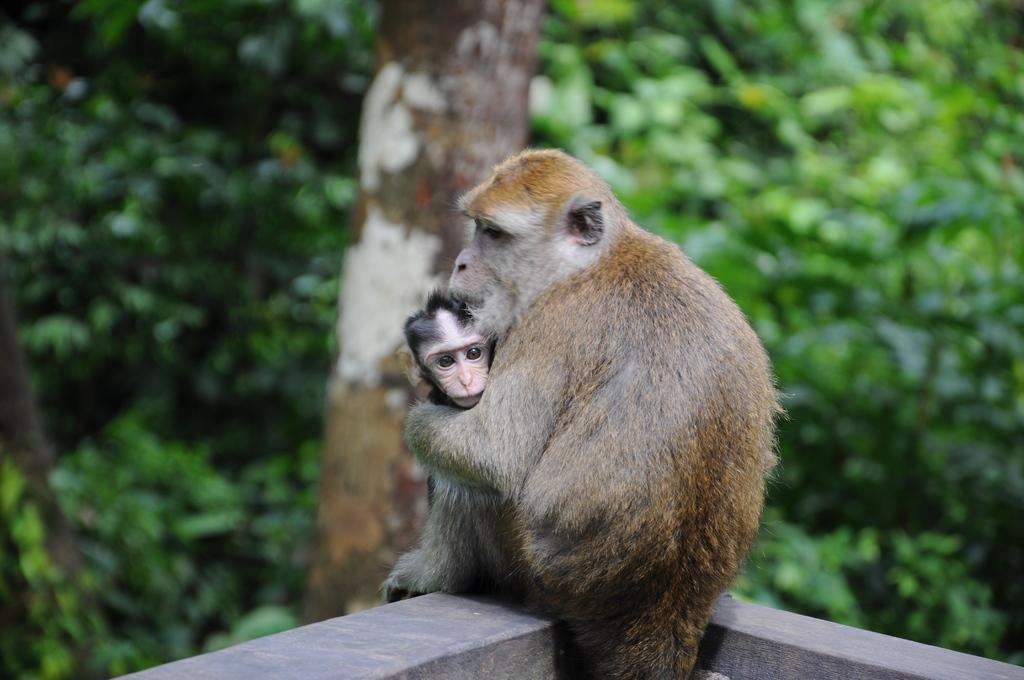Can you describe this image briefly? In this image I can see a mother monkey holding a baby monkey in her lap with a blurred background. 